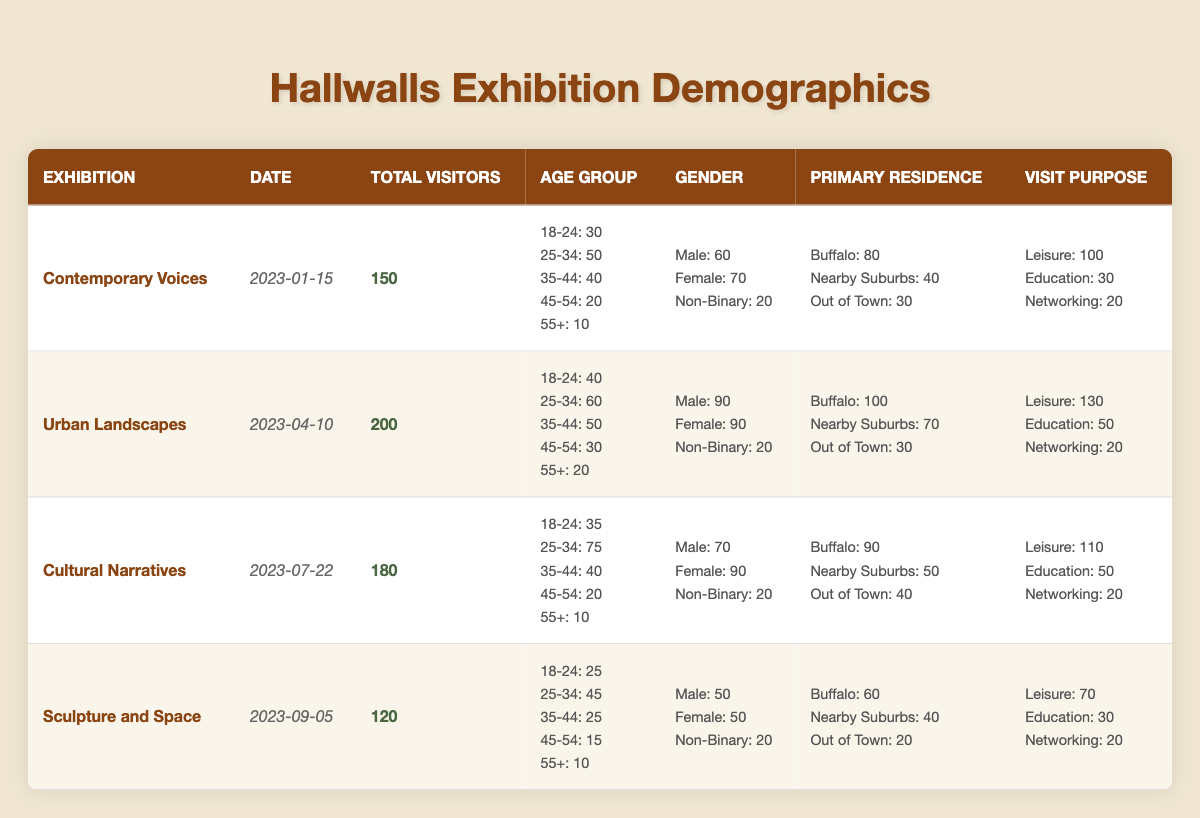What was the total number of visitors for the exhibition "Urban Landscapes"? The total number of visitors for "Urban Landscapes" is listed directly in the table under the "Total Visitors" column, which shows the value as 200.
Answer: 200 Which exhibition had the least number of visitors? To determine which exhibition had the least number of visitors, I will compare the total visitors for each exhibition listed in the "Total Visitors" column. "Sculpture and Space" has the lowest value at 120.
Answer: Sculpture and Space What percentage of visitors for the exhibition "Cultural Narratives" were male? The total visitors for "Cultural Narratives" is 180. There are 70 male visitors, so the percentage is calculated as (70/180) * 100 = 38.89%.
Answer: Approximately 38.89% How many more visitors came from Buffalo than from out of town for the "Contemporary Voices" exhibition? For the "Contemporary Voices" exhibition, the number of visitors from Buffalo is 80, and the number from out of town is 30. The difference is 80 - 30 = 50.
Answer: 50 Did the exhibition "Sculpture and Space" attract more leisure-focused visitors than educational-focused visitors? For "Sculpture and Space," the number of leisure visitors is 70, while the educational visitors are 30. Since 70 is greater than 30, the answer is yes.
Answer: Yes What is the average number of non-binary visitors across all exhibitions? To find the average number of non-binary visitors, I will sum the non-binary visitors from each exhibition: (20 + 20 + 20 + 20) = 80. Then I will divide by the number of exhibitions, which is 4, giving an average of 80/4 = 20.
Answer: 20 Which age group had the most visitors overall across all exhibitions? To find the most populated age group, I will sum the visitors across all exhibitions for each age group: 18-24: (30 + 40 + 35 + 25) = 130, 25-34: (50 + 60 + 75 + 45) = 230, 35-44: (40 + 50 + 40 + 25) = 155, 45-54: (20 + 30 + 20 + 15) = 85, 55+: (10 + 20 + 10 + 10) = 50. The group 25-34 has the most visitors at 230.
Answer: 25-34 Was the gender distribution for the "Urban Landscapes" exhibition equal between males and females? For "Urban Landscapes," there were 90 male visitors and 90 female visitors, making the distribution equal.
Answer: Yes 